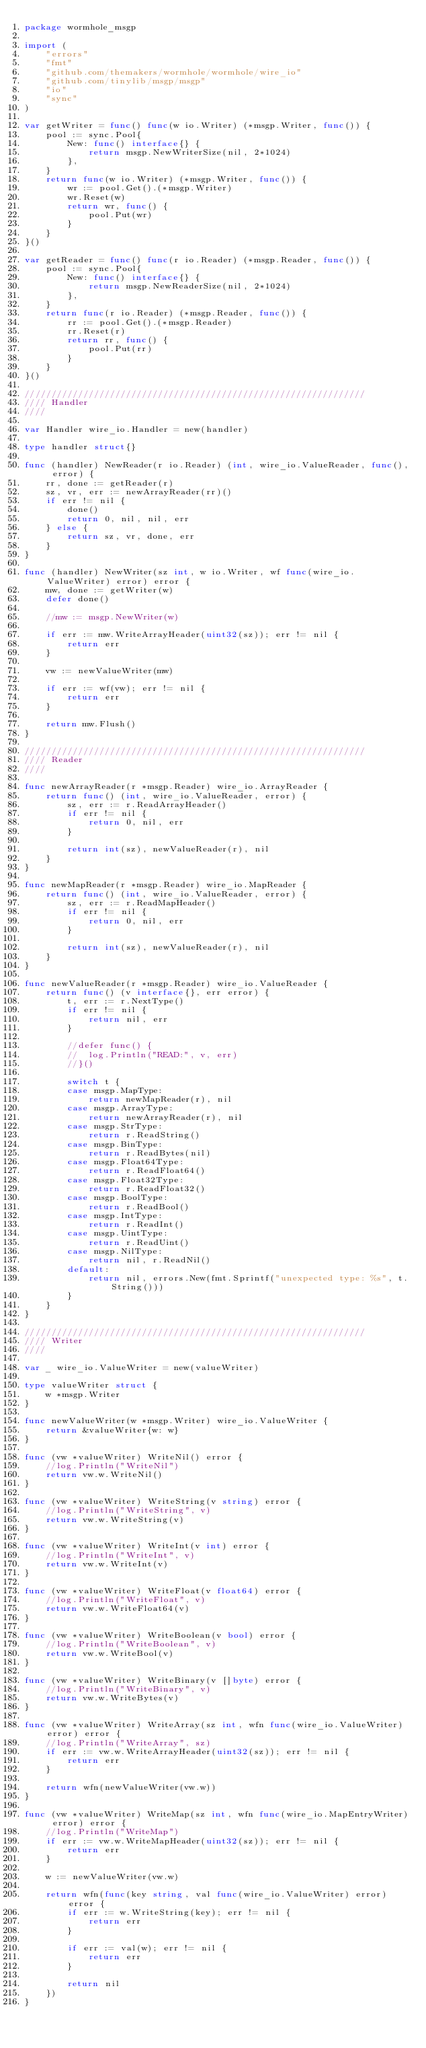Convert code to text. <code><loc_0><loc_0><loc_500><loc_500><_Go_>package wormhole_msgp

import (
	"errors"
	"fmt"
	"github.com/themakers/wormhole/wormhole/wire_io"
	"github.com/tinylib/msgp/msgp"
	"io"
	"sync"
)

var getWriter = func() func(w io.Writer) (*msgp.Writer, func()) {
	pool := sync.Pool{
		New: func() interface{} {
			return msgp.NewWriterSize(nil, 2*1024)
		},
	}
	return func(w io.Writer) (*msgp.Writer, func()) {
		wr := pool.Get().(*msgp.Writer)
		wr.Reset(w)
		return wr, func() {
			pool.Put(wr)
		}
	}
}()

var getReader = func() func(r io.Reader) (*msgp.Reader, func()) {
	pool := sync.Pool{
		New: func() interface{} {
			return msgp.NewReaderSize(nil, 2*1024)
		},
	}
	return func(r io.Reader) (*msgp.Reader, func()) {
		rr := pool.Get().(*msgp.Reader)
		rr.Reset(r)
		return rr, func() {
			pool.Put(rr)
		}
	}
}()

////////////////////////////////////////////////////////////////
//// Handler
////

var Handler wire_io.Handler = new(handler)

type handler struct{}

func (handler) NewReader(r io.Reader) (int, wire_io.ValueReader, func(), error) {
	rr, done := getReader(r)
	sz, vr, err := newArrayReader(rr)()
	if err != nil {
		done()
		return 0, nil, nil, err
	} else {
		return sz, vr, done, err
	}
}

func (handler) NewWriter(sz int, w io.Writer, wf func(wire_io.ValueWriter) error) error {
	mw, done := getWriter(w)
	defer done()

	//mw := msgp.NewWriter(w)

	if err := mw.WriteArrayHeader(uint32(sz)); err != nil {
		return err
	}

	vw := newValueWriter(mw)

	if err := wf(vw); err != nil {
		return err
	}

	return mw.Flush()
}

////////////////////////////////////////////////////////////////
//// Reader
////

func newArrayReader(r *msgp.Reader) wire_io.ArrayReader {
	return func() (int, wire_io.ValueReader, error) {
		sz, err := r.ReadArrayHeader()
		if err != nil {
			return 0, nil, err
		}

		return int(sz), newValueReader(r), nil
	}
}

func newMapReader(r *msgp.Reader) wire_io.MapReader {
	return func() (int, wire_io.ValueReader, error) {
		sz, err := r.ReadMapHeader()
		if err != nil {
			return 0, nil, err
		}

		return int(sz), newValueReader(r), nil
	}
}

func newValueReader(r *msgp.Reader) wire_io.ValueReader {
	return func() (v interface{}, err error) {
		t, err := r.NextType()
		if err != nil {
			return nil, err
		}

		//defer func() {
		//	log.Println("READ:", v, err)
		//}()

		switch t {
		case msgp.MapType:
			return newMapReader(r), nil
		case msgp.ArrayType:
			return newArrayReader(r), nil
		case msgp.StrType:
			return r.ReadString()
		case msgp.BinType:
			return r.ReadBytes(nil)
		case msgp.Float64Type:
			return r.ReadFloat64()
		case msgp.Float32Type:
			return r.ReadFloat32()
		case msgp.BoolType:
			return r.ReadBool()
		case msgp.IntType:
			return r.ReadInt()
		case msgp.UintType:
			return r.ReadUint()
		case msgp.NilType:
			return nil, r.ReadNil()
		default:
			return nil, errors.New(fmt.Sprintf("unexpected type: %s", t.String()))
		}
	}
}

////////////////////////////////////////////////////////////////
//// Writer
////

var _ wire_io.ValueWriter = new(valueWriter)

type valueWriter struct {
	w *msgp.Writer
}

func newValueWriter(w *msgp.Writer) wire_io.ValueWriter {
	return &valueWriter{w: w}
}

func (vw *valueWriter) WriteNil() error {
	//log.Println("WriteNil")
	return vw.w.WriteNil()
}

func (vw *valueWriter) WriteString(v string) error {
	//log.Println("WriteString", v)
	return vw.w.WriteString(v)
}

func (vw *valueWriter) WriteInt(v int) error {
	//log.Println("WriteInt", v)
	return vw.w.WriteInt(v)
}

func (vw *valueWriter) WriteFloat(v float64) error {
	//log.Println("WriteFloat", v)
	return vw.w.WriteFloat64(v)
}

func (vw *valueWriter) WriteBoolean(v bool) error {
	//log.Println("WriteBoolean", v)
	return vw.w.WriteBool(v)
}

func (vw *valueWriter) WriteBinary(v []byte) error {
	//log.Println("WriteBinary", v)
	return vw.w.WriteBytes(v)
}

func (vw *valueWriter) WriteArray(sz int, wfn func(wire_io.ValueWriter) error) error {
	//log.Println("WriteArray", sz)
	if err := vw.w.WriteArrayHeader(uint32(sz)); err != nil {
		return err
	}

	return wfn(newValueWriter(vw.w))
}

func (vw *valueWriter) WriteMap(sz int, wfn func(wire_io.MapEntryWriter) error) error {
	//log.Println("WriteMap")
	if err := vw.w.WriteMapHeader(uint32(sz)); err != nil {
		return err
	}

	w := newValueWriter(vw.w)

	return wfn(func(key string, val func(wire_io.ValueWriter) error) error {
		if err := w.WriteString(key); err != nil {
			return err
		}

		if err := val(w); err != nil {
			return err
		}

		return nil
	})
}
</code> 